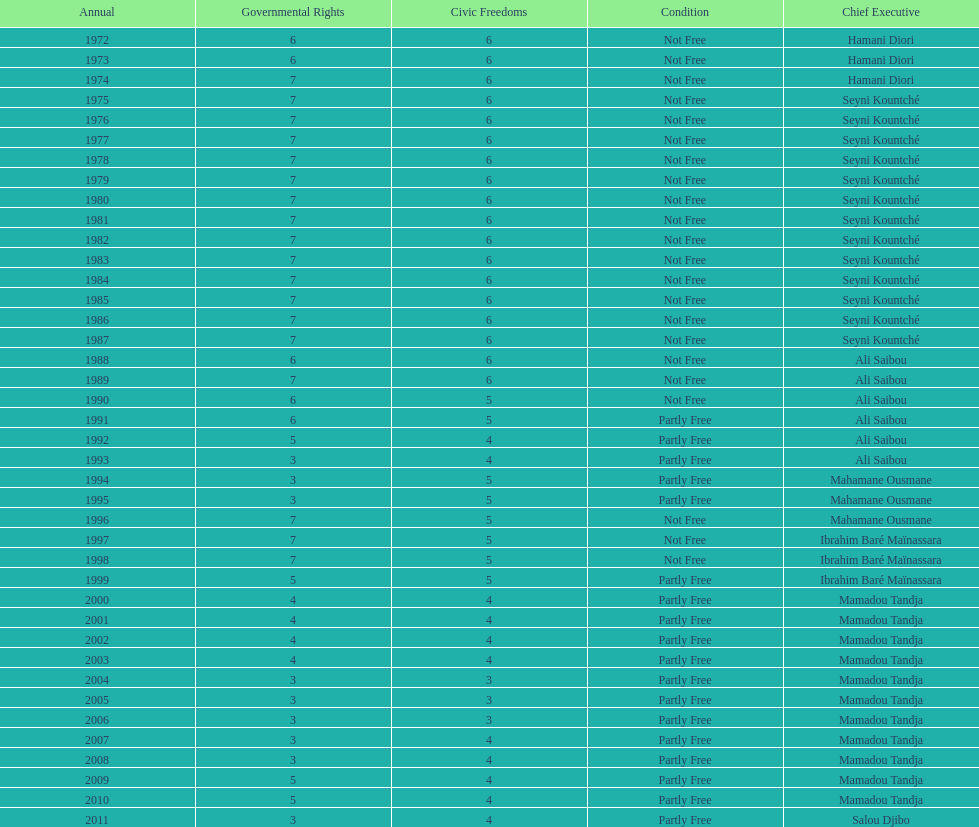How long did it take for civil liberties to decrease below 6? 18 years. 